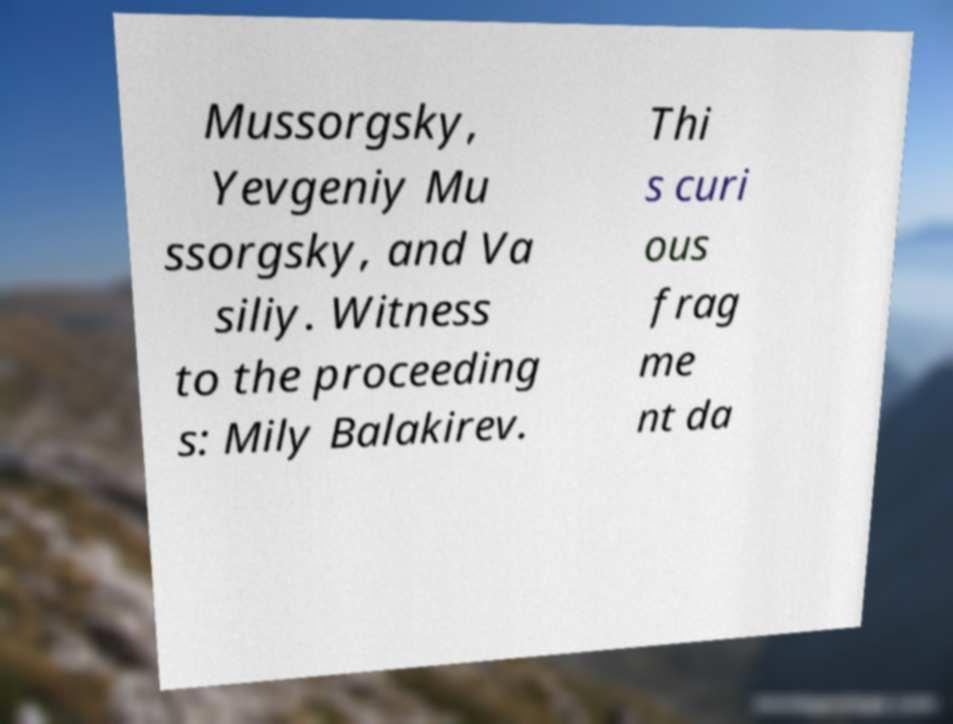There's text embedded in this image that I need extracted. Can you transcribe it verbatim? Mussorgsky, Yevgeniy Mu ssorgsky, and Va siliy. Witness to the proceeding s: Mily Balakirev. Thi s curi ous frag me nt da 